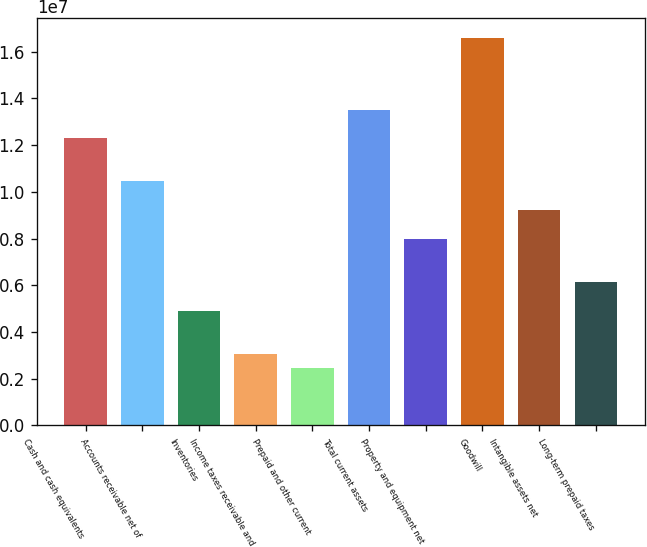<chart> <loc_0><loc_0><loc_500><loc_500><bar_chart><fcel>Cash and cash equivalents<fcel>Accounts receivable net of<fcel>Inventories<fcel>Income taxes receivable and<fcel>Prepaid and other current<fcel>Total current assets<fcel>Property and equipment net<fcel>Goodwill<fcel>Intangible assets net<fcel>Long-term prepaid taxes<nl><fcel>1.22905e+07<fcel>1.04471e+07<fcel>4.91708e+06<fcel>3.07373e+06<fcel>2.45929e+06<fcel>1.35194e+07<fcel>7.98932e+06<fcel>1.65916e+07<fcel>9.21821e+06<fcel>6.14597e+06<nl></chart> 